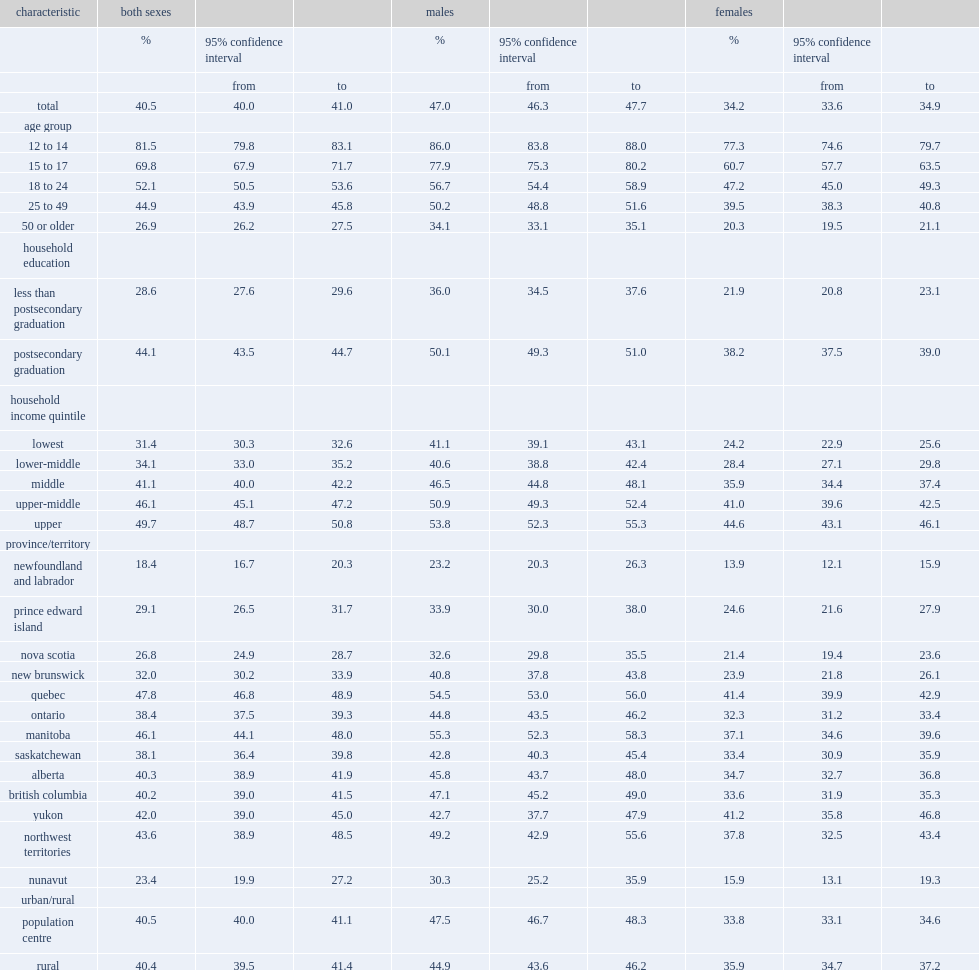In 2013/2014, what is the percentage of canadians aged 12 or older reported that they had cycled in the previous year? 40.5. What is the percentage of canadians aged 12- to 14-year-olds had cycled in the previous year? 81.5. What is the percentage of canadians aged 50 or older had cycled in the previous year? 26.9. Who were more likely to have cycled in the past year regardless of age, income or education,males or females? Males. In the previous year,which place males were more likely to have cycled in, population centres or in rural areas to cycle? Population centre. In the previous year,which place females were more likely to have cycled in, population centres or in rural areas to cycle? Rural. What is the percentage of people in quebec had cycled in the previous year? 47.8. What is the percentage of people in manitoba had cycled in the previous year? 46.1. What is the percentage of people in newfoundland had cycled in the previous year? 18.4. What is the percentage of people in new brunswick had cycled in the previous year? 32.0. What is the percentage of people in saskatchewan had cycled in the previous year? 38.1. What is the percentage of people in ontario had cycled in the previous year? 38.4. What is the percentage of people in nunavut had cycled in the previous year? 23.4. 